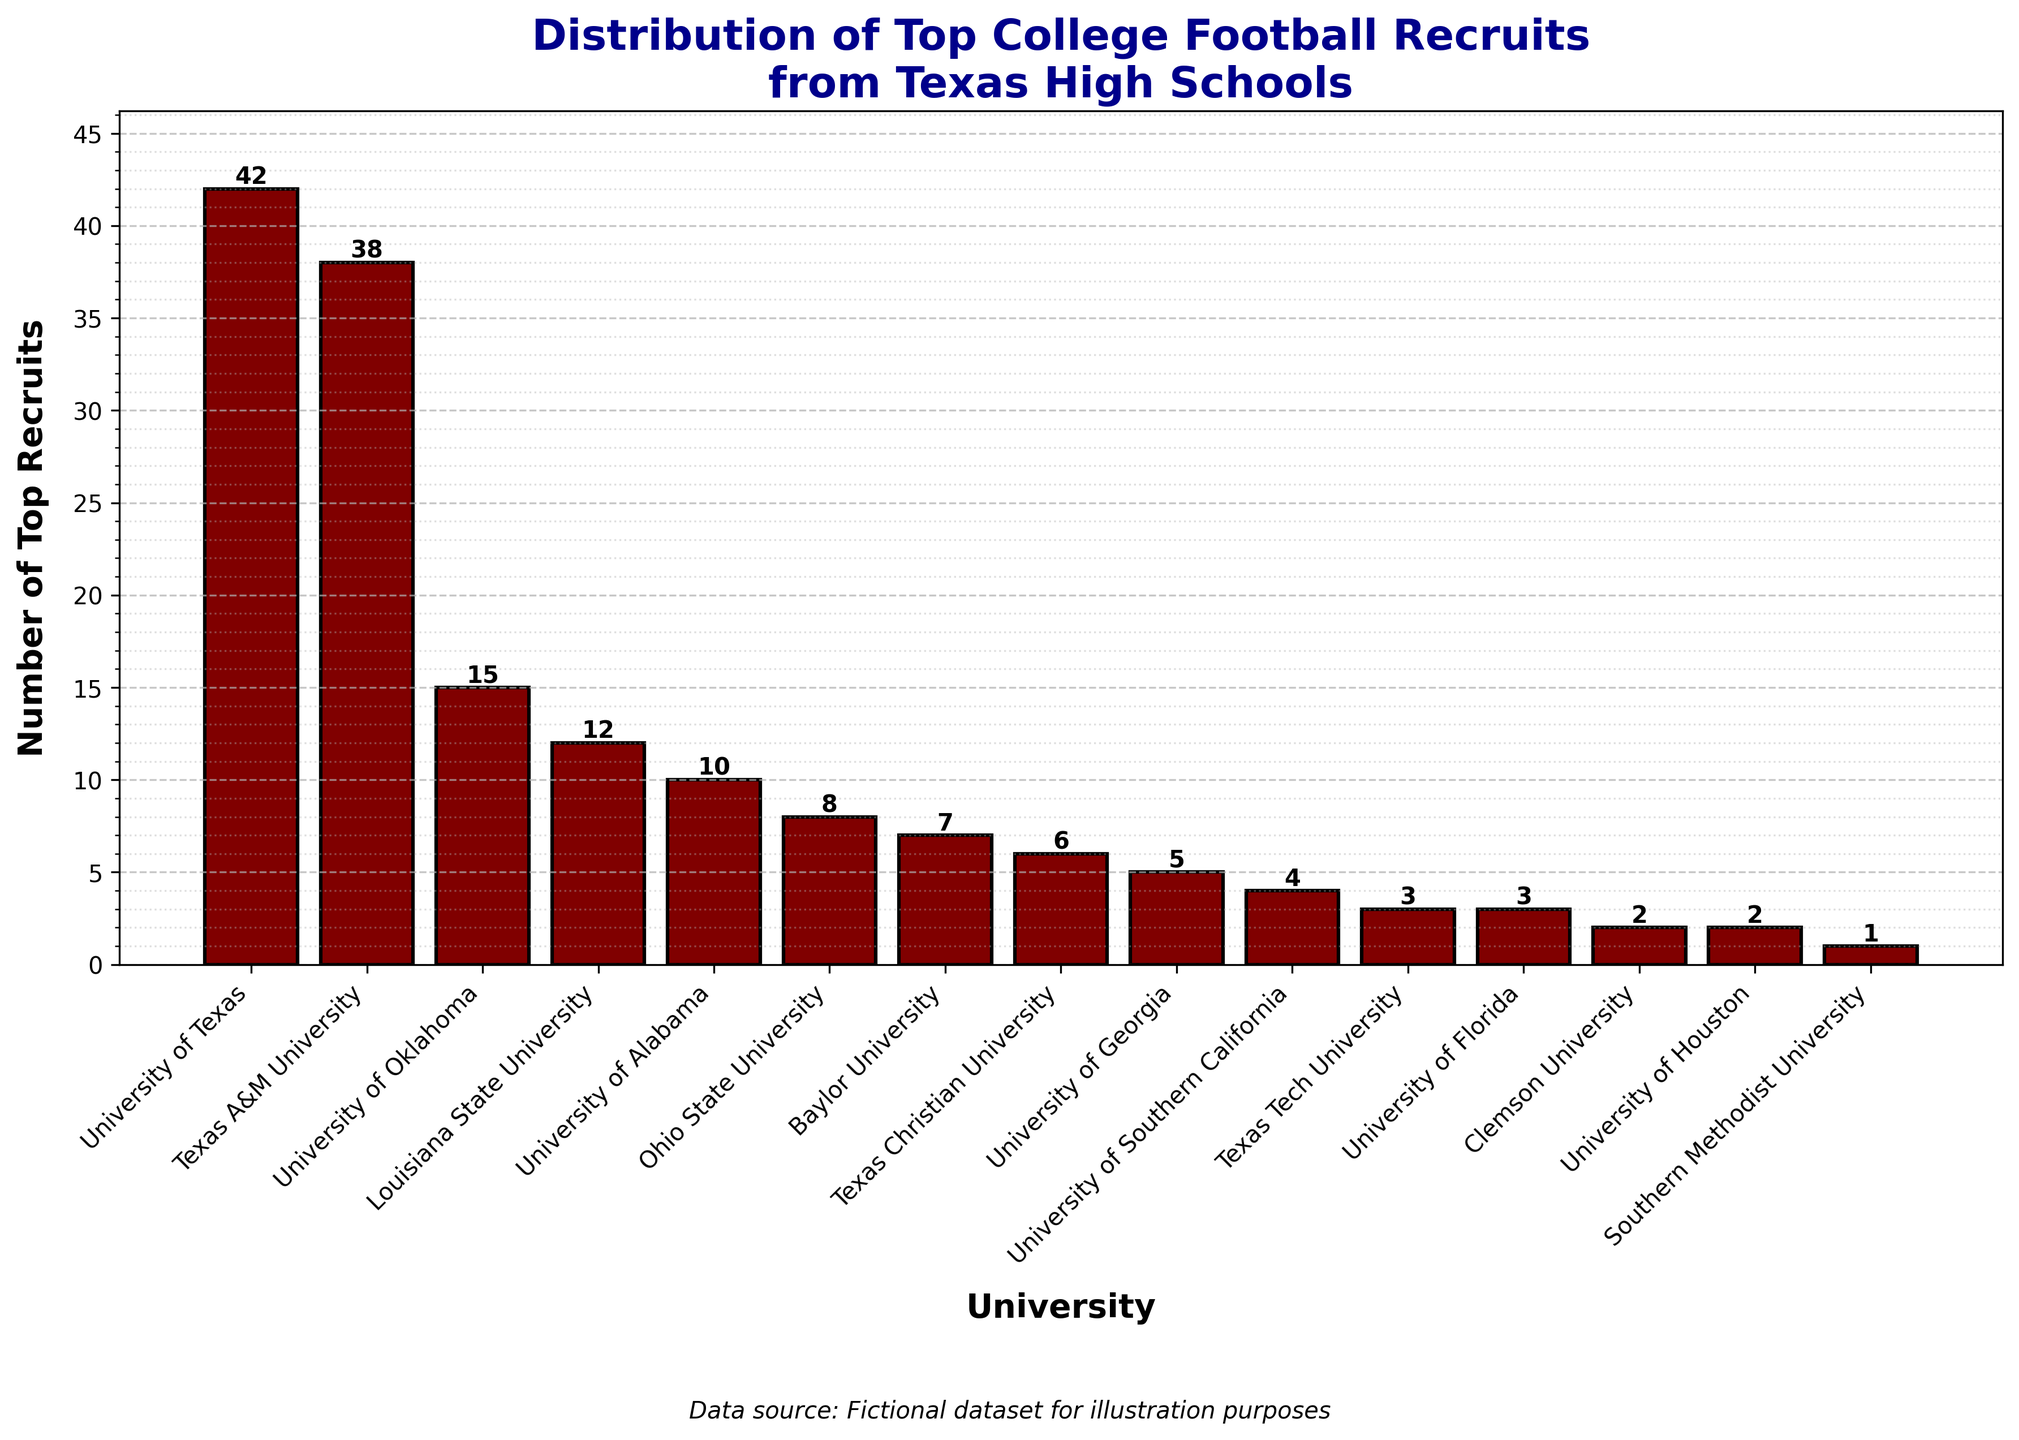Which university has the highest number of top recruits from Texas high schools? The bar representing the University of Texas is the tallest in the chart, indicating it has the highest number of top recruits.
Answer: University of Texas How many top recruits do the University of Oklahoma and Louisiana State University have combined? The University of Oklahoma has 15 recruits and Louisiana State University has 12 recruits. Adding them together gives 15 + 12 = 27.
Answer: 27 Which university has more top recruits, Baylor University or Texas Christian University? Baylor University has a bar that reaches 7 recruits, while Texas Christian University has a bar that reaches 6 recruits.
Answer: Baylor University What is the total number of top recruits for the University of Southern California, Texas Tech University, and Clemson University? University of Southern California has 4 recruits, Texas Tech University has 3 recruits, and Clemson University has 2 recruits. Adding them together gives 4 + 3 + 2 = 9.
Answer: 9 Compared to Ohio State University, how many more top recruits does Texas A&M University have? Texas A&M University has 38 top recruits, while Ohio State University has 8. The difference is 38 - 8 = 30.
Answer: 30 Which universities have fewer than 5 top recruits from Texas high schools? Universities with fewer than 5 recruits are University of Southern California (4 recruits), Texas Tech University (3 recruits), University of Florida (3 recruits), Clemson University (2 recruits), University of Houston (2 recruits), and Southern Methodist University (1 recruit).
Answer: University of Southern California, Texas Tech University, University of Florida, Clemson University, University of Houston, Southern Methodist University What is the average number of top recruits among universities that have more than 10 recruits? Universities with more than 10 recruits include University of Texas (42), Texas A&M University (38), University of Oklahoma (15), and Louisiana State University (12). The average is calculated as (42 + 38 + 15 + 12) / 4 = 107 / 4 = 26.75.
Answer: 26.75 How does the number of top recruits for the University of Alabama compare to the University of Georgia? The University of Alabama has a bar that reaches 10 recruits, while the University of Georgia has a bar that reaches 5 recruits. The University of Alabama has more top recruits.
Answer: The University of Alabama has more recruits Considering only recruits to Texas-based universities, how many universities have at least 10 recruits? Texas-based universities with at least 10 recruits are University of Texas (42) and Texas A&M University (38). So there are 2 universities.
Answer: 2 Which university has the lowest number of top recruits? The shortest bar in the chart represents Southern Methodist University, which has 1 recruit.
Answer: Southern Methodist University 